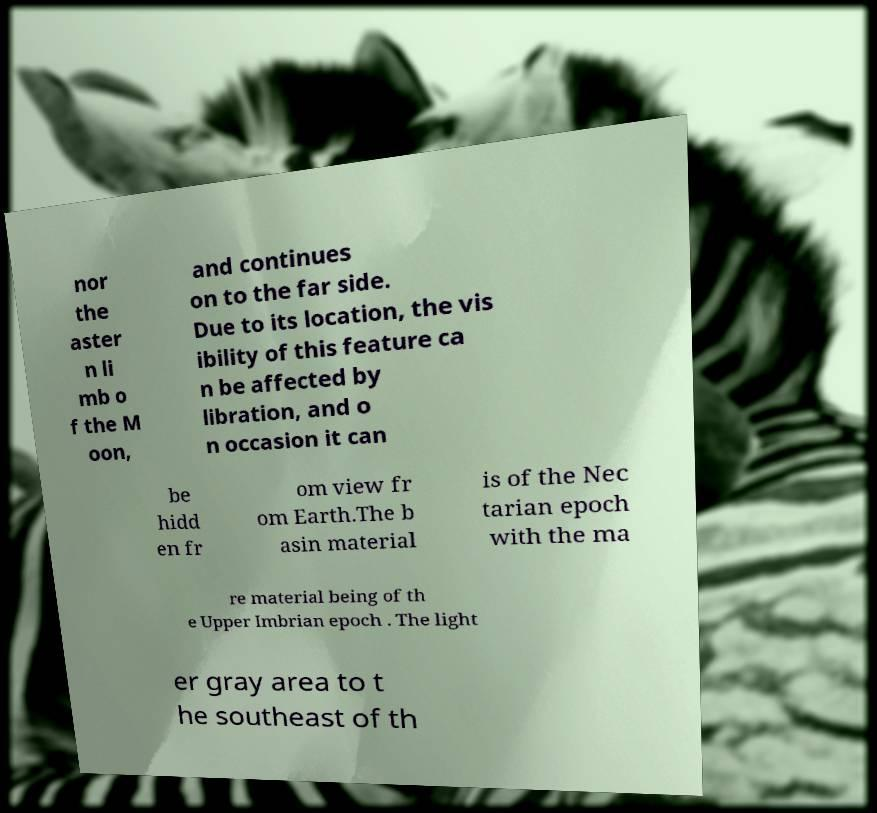Could you assist in decoding the text presented in this image and type it out clearly? nor the aster n li mb o f the M oon, and continues on to the far side. Due to its location, the vis ibility of this feature ca n be affected by libration, and o n occasion it can be hidd en fr om view fr om Earth.The b asin material is of the Nec tarian epoch with the ma re material being of th e Upper Imbrian epoch . The light er gray area to t he southeast of th 